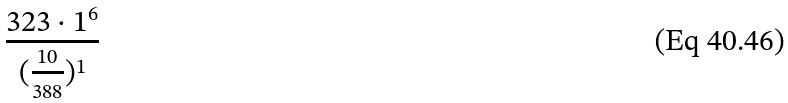<formula> <loc_0><loc_0><loc_500><loc_500>\frac { 3 2 3 \cdot 1 ^ { 6 } } { ( \frac { 1 0 } { 3 8 8 } ) ^ { 1 } }</formula> 